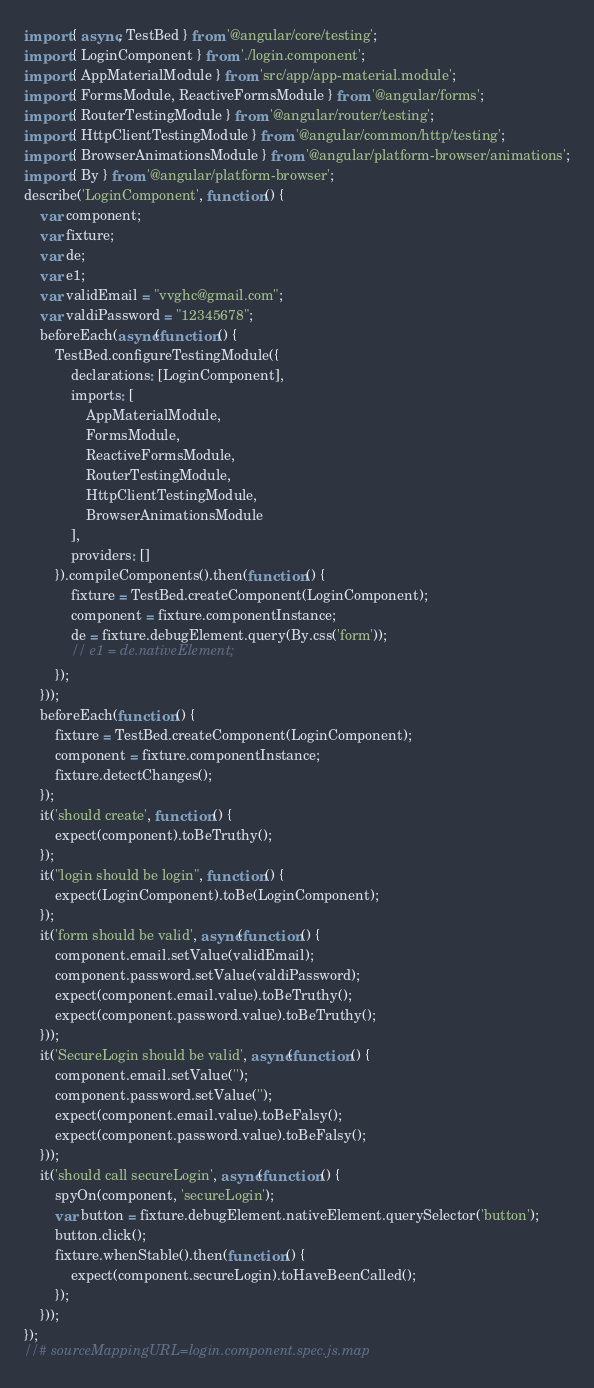<code> <loc_0><loc_0><loc_500><loc_500><_JavaScript_>import { async, TestBed } from '@angular/core/testing';
import { LoginComponent } from './login.component';
import { AppMaterialModule } from 'src/app/app-material.module';
import { FormsModule, ReactiveFormsModule } from '@angular/forms';
import { RouterTestingModule } from '@angular/router/testing';
import { HttpClientTestingModule } from '@angular/common/http/testing';
import { BrowserAnimationsModule } from '@angular/platform-browser/animations';
import { By } from '@angular/platform-browser';
describe('LoginComponent', function () {
    var component;
    var fixture;
    var de;
    var e1;
    var validEmail = "vvghc@gmail.com";
    var valdiPassword = "12345678";
    beforeEach(async(function () {
        TestBed.configureTestingModule({
            declarations: [LoginComponent],
            imports: [
                AppMaterialModule,
                FormsModule,
                ReactiveFormsModule,
                RouterTestingModule,
                HttpClientTestingModule,
                BrowserAnimationsModule
            ],
            providers: []
        }).compileComponents().then(function () {
            fixture = TestBed.createComponent(LoginComponent);
            component = fixture.componentInstance;
            de = fixture.debugElement.query(By.css('form'));
            // e1 = de.nativeElement;
        });
    }));
    beforeEach(function () {
        fixture = TestBed.createComponent(LoginComponent);
        component = fixture.componentInstance;
        fixture.detectChanges();
    });
    it('should create', function () {
        expect(component).toBeTruthy();
    });
    it("login should be login", function () {
        expect(LoginComponent).toBe(LoginComponent);
    });
    it('form should be valid', async(function () {
        component.email.setValue(validEmail);
        component.password.setValue(valdiPassword);
        expect(component.email.value).toBeTruthy();
        expect(component.password.value).toBeTruthy();
    }));
    it('SecureLogin should be valid', async(function () {
        component.email.setValue('');
        component.password.setValue('');
        expect(component.email.value).toBeFalsy();
        expect(component.password.value).toBeFalsy();
    }));
    it('should call secureLogin', async(function () {
        spyOn(component, 'secureLogin');
        var button = fixture.debugElement.nativeElement.querySelector('button');
        button.click();
        fixture.whenStable().then(function () {
            expect(component.secureLogin).toHaveBeenCalled();
        });
    }));
});
//# sourceMappingURL=login.component.spec.js.map</code> 